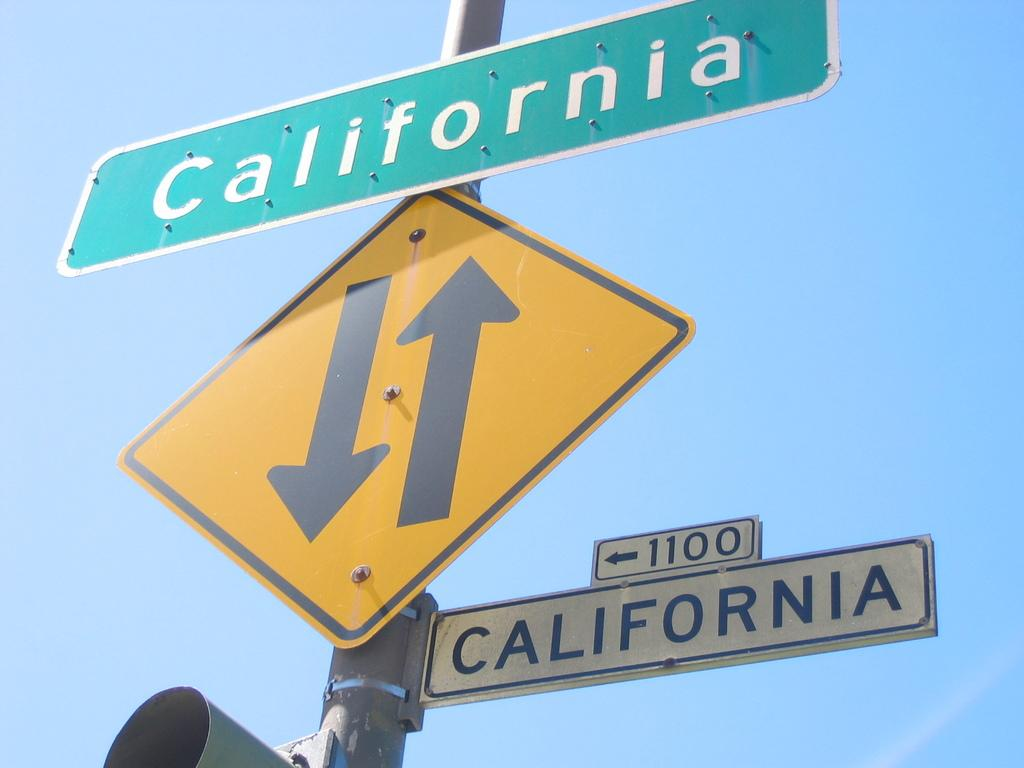<image>
Relay a brief, clear account of the picture shown. Two signs say California, one in green and the other white. 